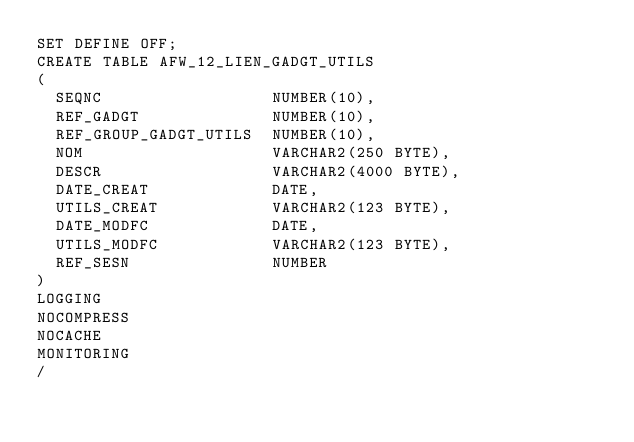<code> <loc_0><loc_0><loc_500><loc_500><_SQL_>SET DEFINE OFF;
CREATE TABLE AFW_12_LIEN_GADGT_UTILS
(
  SEQNC                  NUMBER(10),
  REF_GADGT              NUMBER(10),
  REF_GROUP_GADGT_UTILS  NUMBER(10),
  NOM                    VARCHAR2(250 BYTE),
  DESCR                  VARCHAR2(4000 BYTE),
  DATE_CREAT             DATE,
  UTILS_CREAT            VARCHAR2(123 BYTE),
  DATE_MODFC             DATE,
  UTILS_MODFC            VARCHAR2(123 BYTE),
  REF_SESN               NUMBER
)
LOGGING 
NOCOMPRESS 
NOCACHE
MONITORING
/
</code> 